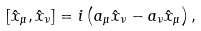Convert formula to latex. <formula><loc_0><loc_0><loc_500><loc_500>[ \hat { x } _ { \mu } , \hat { x } _ { \nu } ] = i \left ( a _ { \mu } \hat { x } _ { \nu } - a _ { \nu } \hat { x } _ { \mu } \right ) ,</formula> 